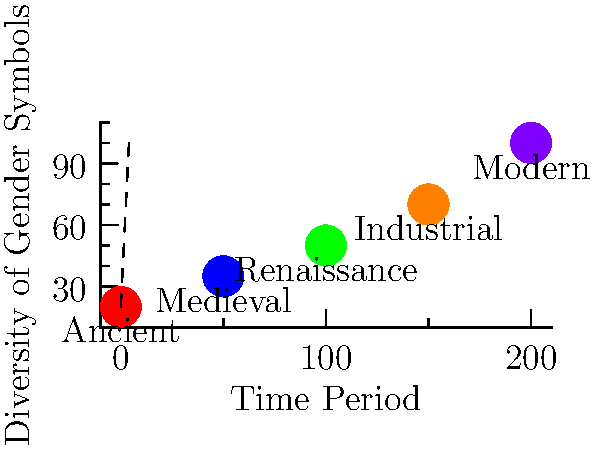Analyze the graph depicting the evolution of gender symbols and icons across different historical periods. What trend does this visualization suggest about the diversity of gender representations over time, and how might this relate to societal changes in gender perception? 1. Observe the graph: The x-axis represents different historical periods, while the y-axis represents the diversity of gender symbols.

2. Analyze the trend: There's a clear upward trend from left to right, indicating an increase in the diversity of gender symbols over time.

3. Period-specific observations:
   - Ancient period: Lowest diversity, suggesting limited gender representations.
   - Medieval period: Slight increase, possibly due to cultural exchanges.
   - Renaissance: Notable jump, coinciding with cultural and artistic revolutions.
   - Industrial era: Continued increase, possibly influenced by social changes.
   - Modern era: Highest diversity, reflecting contemporary gender discussions.

4. Interpret the trend: The increasing diversity suggests a broadening understanding and acceptance of gender identities over time.

5. Consider societal factors:
   - Increased global communication and cultural exchange.
   - Advancements in gender studies and feminist movements.
   - Shifts in social norms and legal recognitions of diverse gender identities.

6. Historical context: The trend aligns with the gradual challenging of binary gender norms and increased visibility of diverse gender expressions.

7. Conclusion: The graph indicates a progressive expansion in the representation and recognition of diverse gender identities throughout history, reflecting evolving societal perspectives on gender.
Answer: Increasing diversity of gender symbols over time, reflecting evolving societal understanding of gender. 